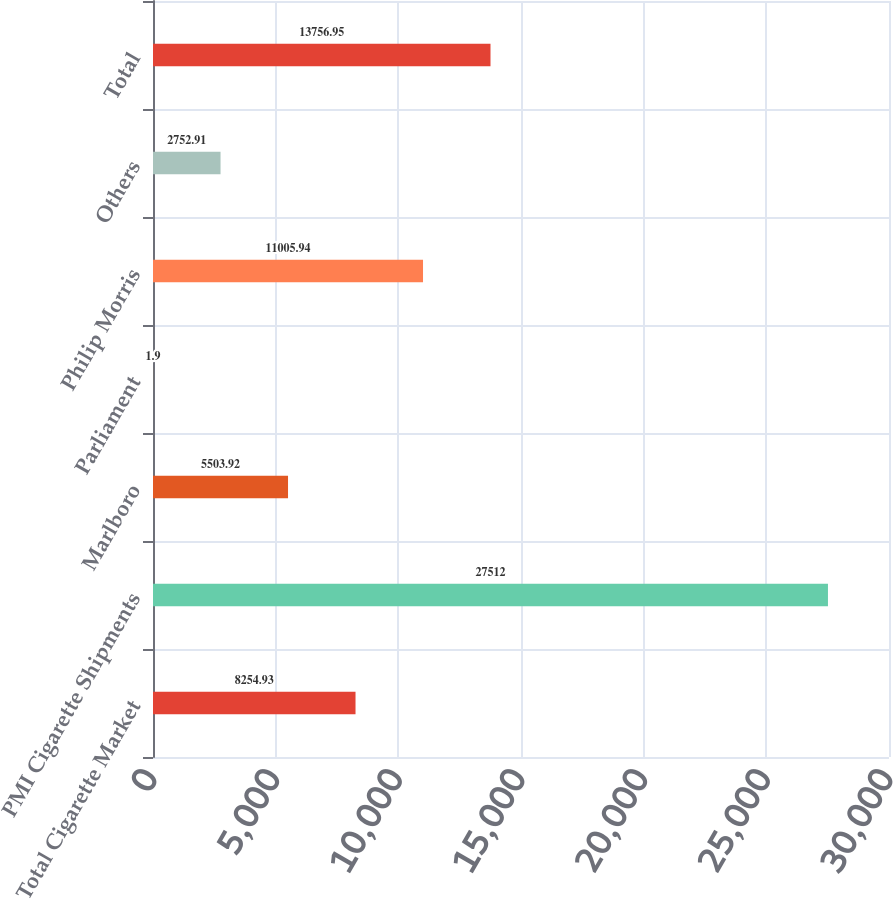Convert chart to OTSL. <chart><loc_0><loc_0><loc_500><loc_500><bar_chart><fcel>Total Cigarette Market<fcel>PMI Cigarette Shipments<fcel>Marlboro<fcel>Parliament<fcel>Philip Morris<fcel>Others<fcel>Total<nl><fcel>8254.93<fcel>27512<fcel>5503.92<fcel>1.9<fcel>11005.9<fcel>2752.91<fcel>13757<nl></chart> 